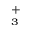<formula> <loc_0><loc_0><loc_500><loc_500>_ { _ { 3 } } ^ { + }</formula> 